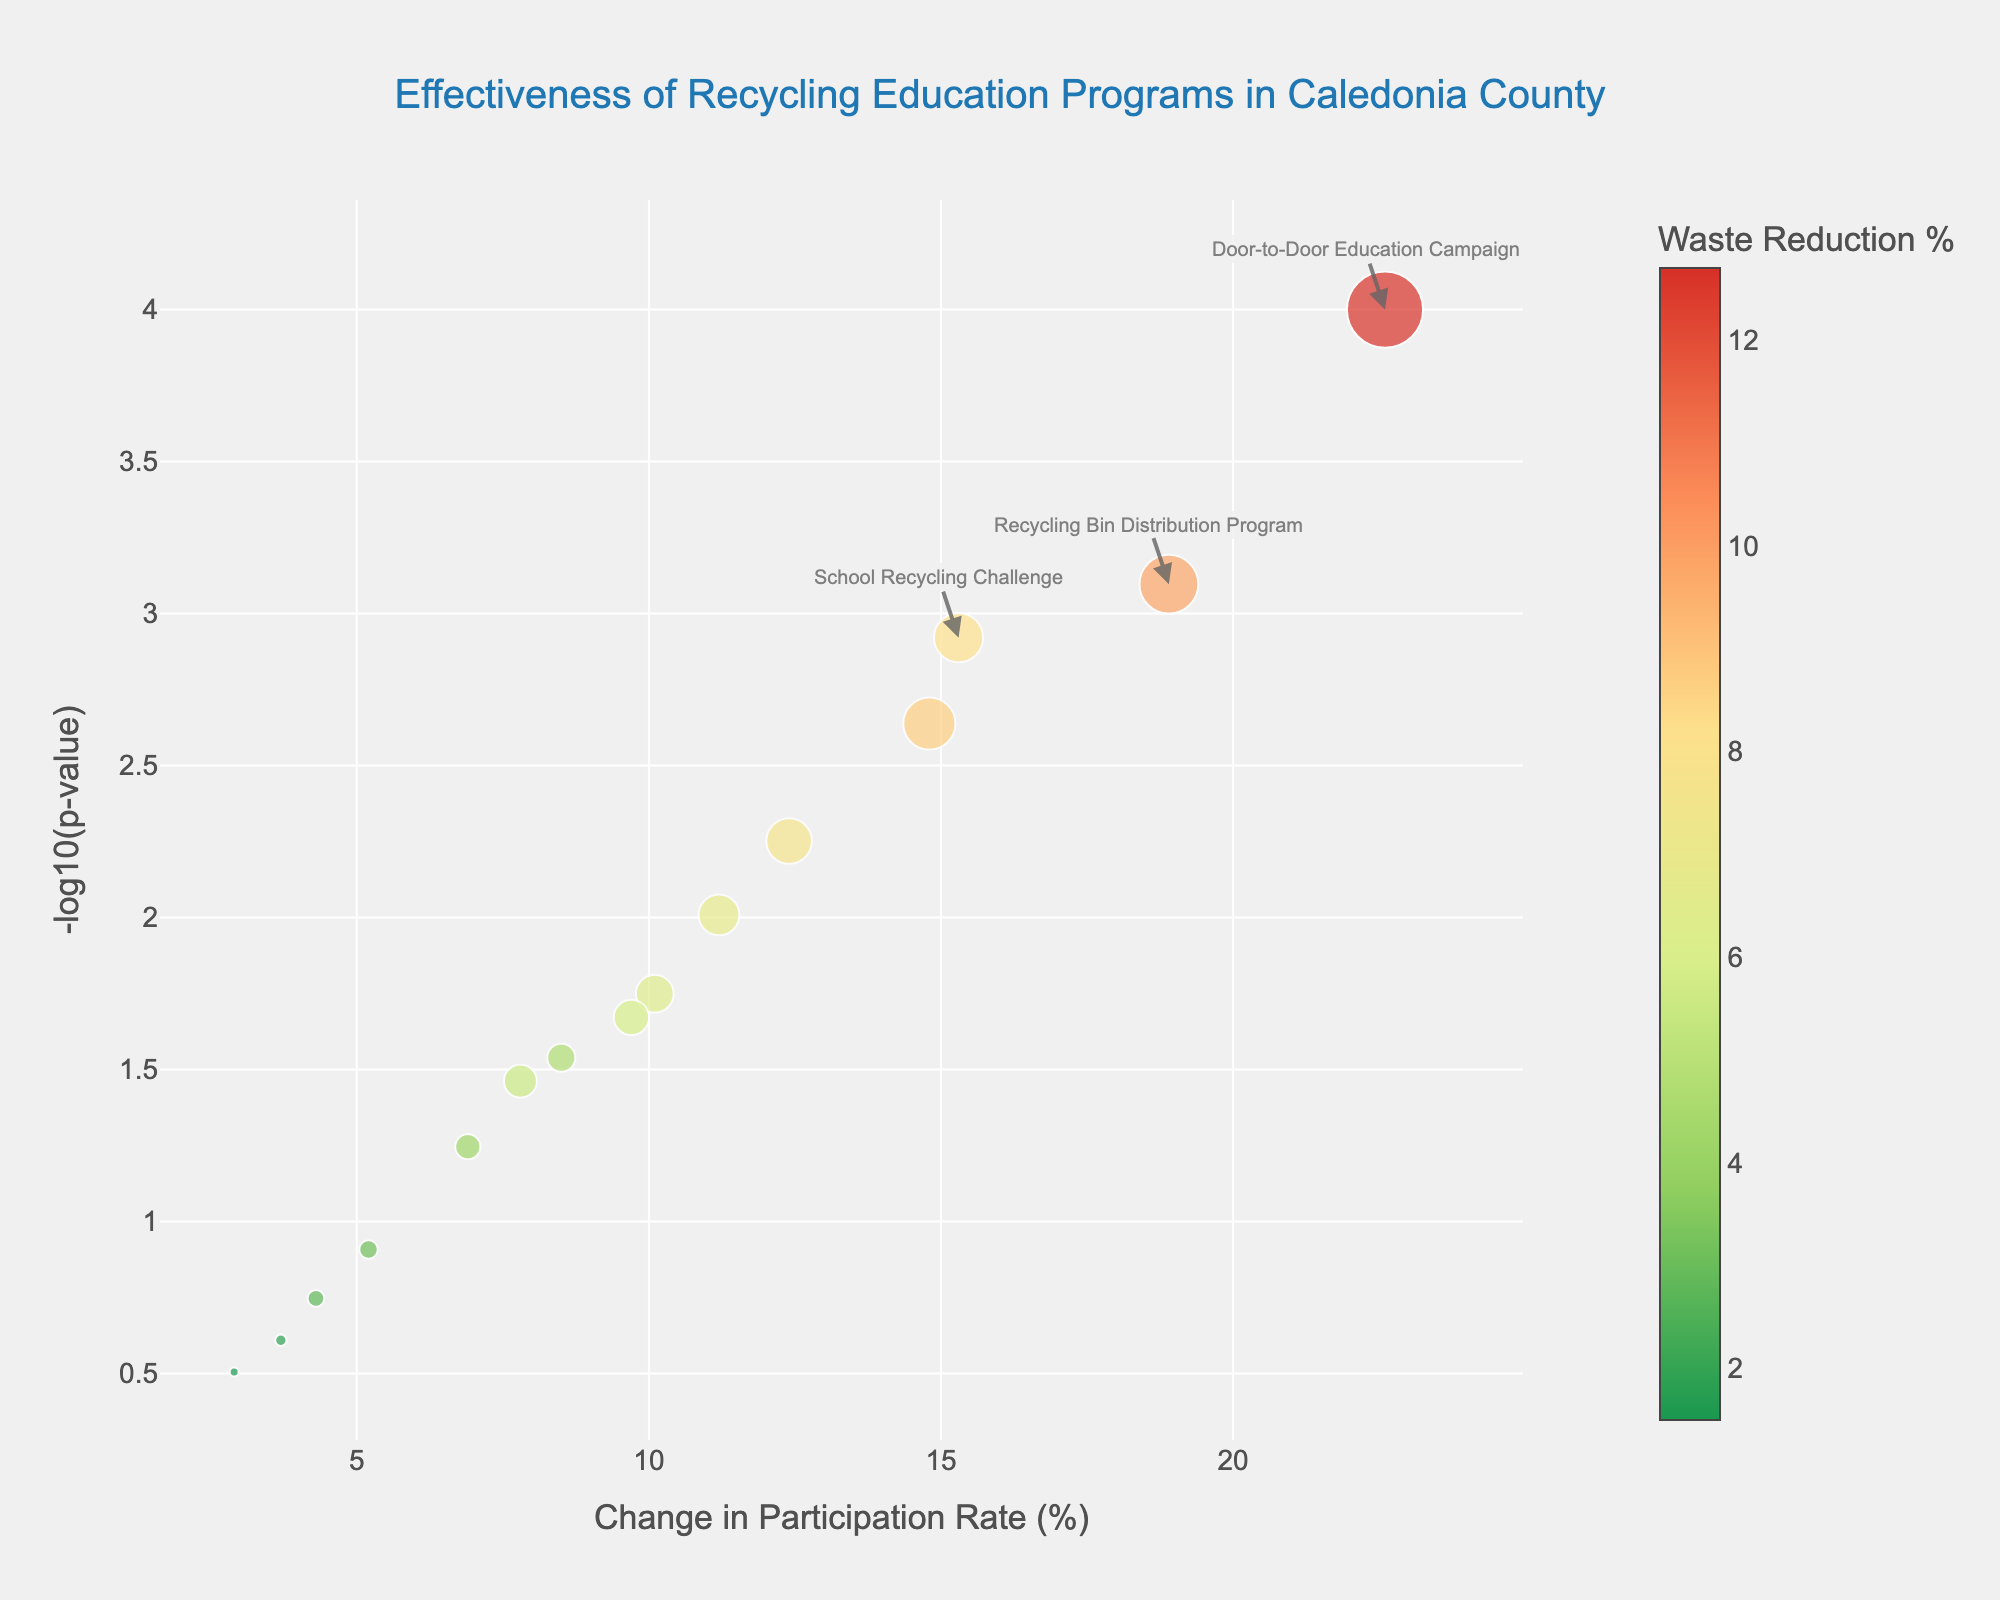How many programs are depicted in the plot? Count the number of distinct data points (bubbles) on the plot. Each bubble represents one program.
Answer: 15 What is the title of the figure? The title is displayed at the top-center of the figure.
Answer: Effectiveness of Recycling Education Programs in Caledonia County Which program shows the greatest change in participation rate? Identify the bubble furthest to the right along the x-axis (Change in Participation Rate). The text associated with this bubble will indicate the program.
Answer: Door-to-Door Education Campaign Which program has the highest significance level (-log10(p-value))? Identify the bubble with the highest position along the y-axis (-log10(p-value)). This bubble's text will indicate the program.
Answer: Door-to-Door Education Campaign What color scale is used to represent waste reduction percentage? Observe the colors of the bubbles and the associated color bar on the right side of the plot.
Answer: A gradient from green through yellow to red Which programs have both high change in participation rate and high waste reduction percentage? Look for larger bubbles positioned on the higher end of the x-axis and mid to high range of waste reduction percentage. Cross-referencing with the respective program annotations if visible.
Answer: Door-to-Door Education Campaign, Recycling Bin Distribution Program Are there any programs with low change in participation rate but high significance? Identify any bubbles situated close to the y-axis (low x-axis value) but high on the y-axis (high -log10(p-value)).
Answer: Recycling Facility Tours, Waste Reduction Pledge Drive Which programs are annotated on the plot? Locate the text annotations directly on the plot. This emphasizes programs with high significance and high participation rate changes.
Answer: Door-to-Door Education Campaign, Recycling Bin Distribution Program How do the Electronic Waste Collection Events compare to the Farmers Market Recycling Booth in terms of significance and waste reduction percentage? Compare the vertical positions and bubble sizes of both data points. The higher the bubble, the more significant; the larger the bubble, the greater the waste reduction percentage.
Answer: Electronic Waste Collection Events are more significant and have higher waste reduction percentage If we focus on programs with a p-value < 0.01, how many meet this criterion? Highlight the bubbles with a -log10(p-value) > 2, which corresponds to p-value < 0.01, and count them.
Answer: 6 